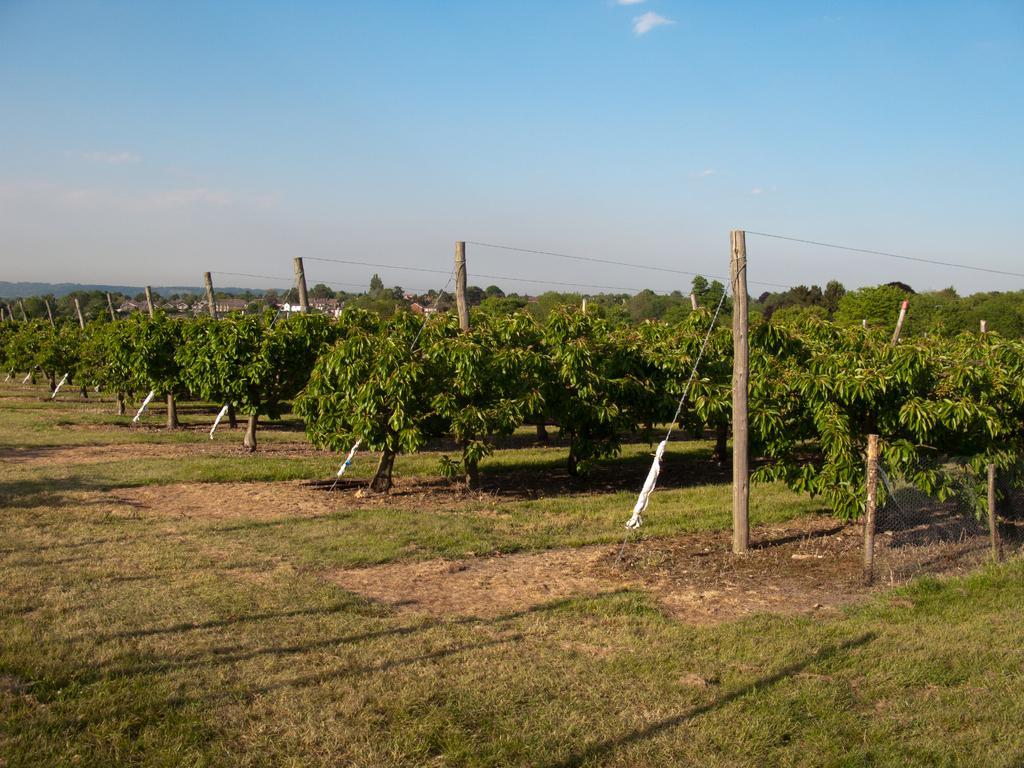In one or two sentences, can you explain what this image depicts? In this picture there is a greenery ground and there are few plants and wooden sticks in front of it and there are trees and buildings in the background. 